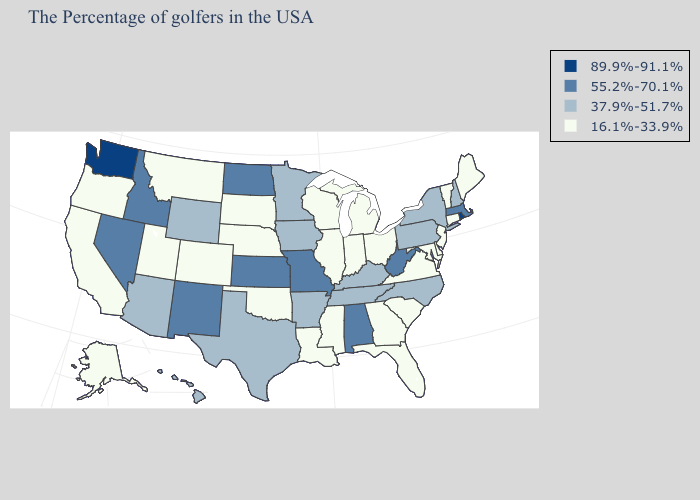Which states hav the highest value in the West?
Give a very brief answer. Washington. Among the states that border Texas , does Oklahoma have the highest value?
Short answer required. No. Name the states that have a value in the range 37.9%-51.7%?
Quick response, please. New Hampshire, New York, Pennsylvania, North Carolina, Kentucky, Tennessee, Arkansas, Minnesota, Iowa, Texas, Wyoming, Arizona, Hawaii. What is the lowest value in the MidWest?
Give a very brief answer. 16.1%-33.9%. Name the states that have a value in the range 37.9%-51.7%?
Be succinct. New Hampshire, New York, Pennsylvania, North Carolina, Kentucky, Tennessee, Arkansas, Minnesota, Iowa, Texas, Wyoming, Arizona, Hawaii. What is the lowest value in states that border California?
Give a very brief answer. 16.1%-33.9%. What is the lowest value in the Northeast?
Concise answer only. 16.1%-33.9%. Name the states that have a value in the range 89.9%-91.1%?
Write a very short answer. Rhode Island, Washington. Does Colorado have the lowest value in the West?
Answer briefly. Yes. Does Rhode Island have the highest value in the Northeast?
Keep it brief. Yes. What is the value of Nevada?
Give a very brief answer. 55.2%-70.1%. What is the value of Tennessee?
Short answer required. 37.9%-51.7%. What is the value of Ohio?
Concise answer only. 16.1%-33.9%. Which states have the lowest value in the South?
Answer briefly. Delaware, Maryland, Virginia, South Carolina, Florida, Georgia, Mississippi, Louisiana, Oklahoma. 